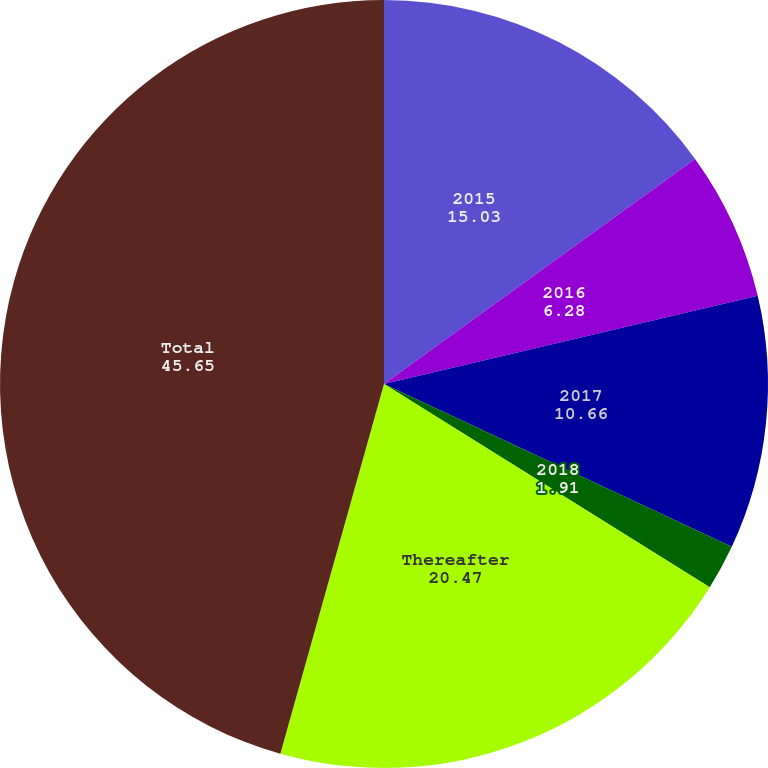Convert chart. <chart><loc_0><loc_0><loc_500><loc_500><pie_chart><fcel>2015<fcel>2016<fcel>2017<fcel>2018<fcel>Thereafter<fcel>Total<nl><fcel>15.03%<fcel>6.28%<fcel>10.66%<fcel>1.91%<fcel>20.47%<fcel>45.65%<nl></chart> 